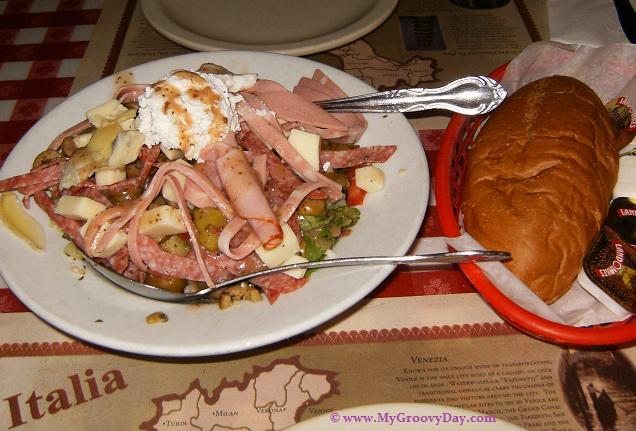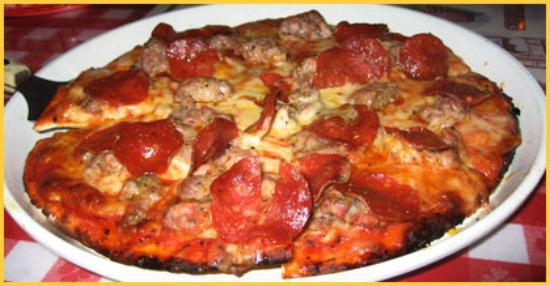The first image is the image on the left, the second image is the image on the right. For the images displayed, is the sentence "The pizza in the image on the left is sitting on a red checked table cloth." factually correct? Answer yes or no. No. The first image is the image on the left, the second image is the image on the right. Assess this claim about the two images: "Two pizzas on white plates are baked and ready to eat, one plate sitting on a red checked tablecloth.". Correct or not? Answer yes or no. No. 